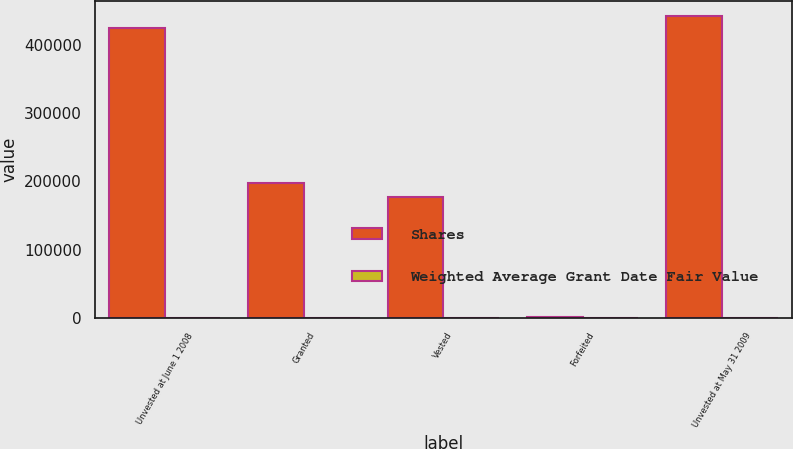<chart> <loc_0><loc_0><loc_500><loc_500><stacked_bar_chart><ecel><fcel>Unvested at June 1 2008<fcel>Granted<fcel>Vested<fcel>Forfeited<fcel>Unvested at May 31 2009<nl><fcel>Shares<fcel>424985<fcel>197180<fcel>177494<fcel>1930<fcel>442741<nl><fcel>Weighted Average Grant Date Fair Value<fcel>103.97<fcel>90.57<fcel>98.05<fcel>100.35<fcel>100.4<nl></chart> 